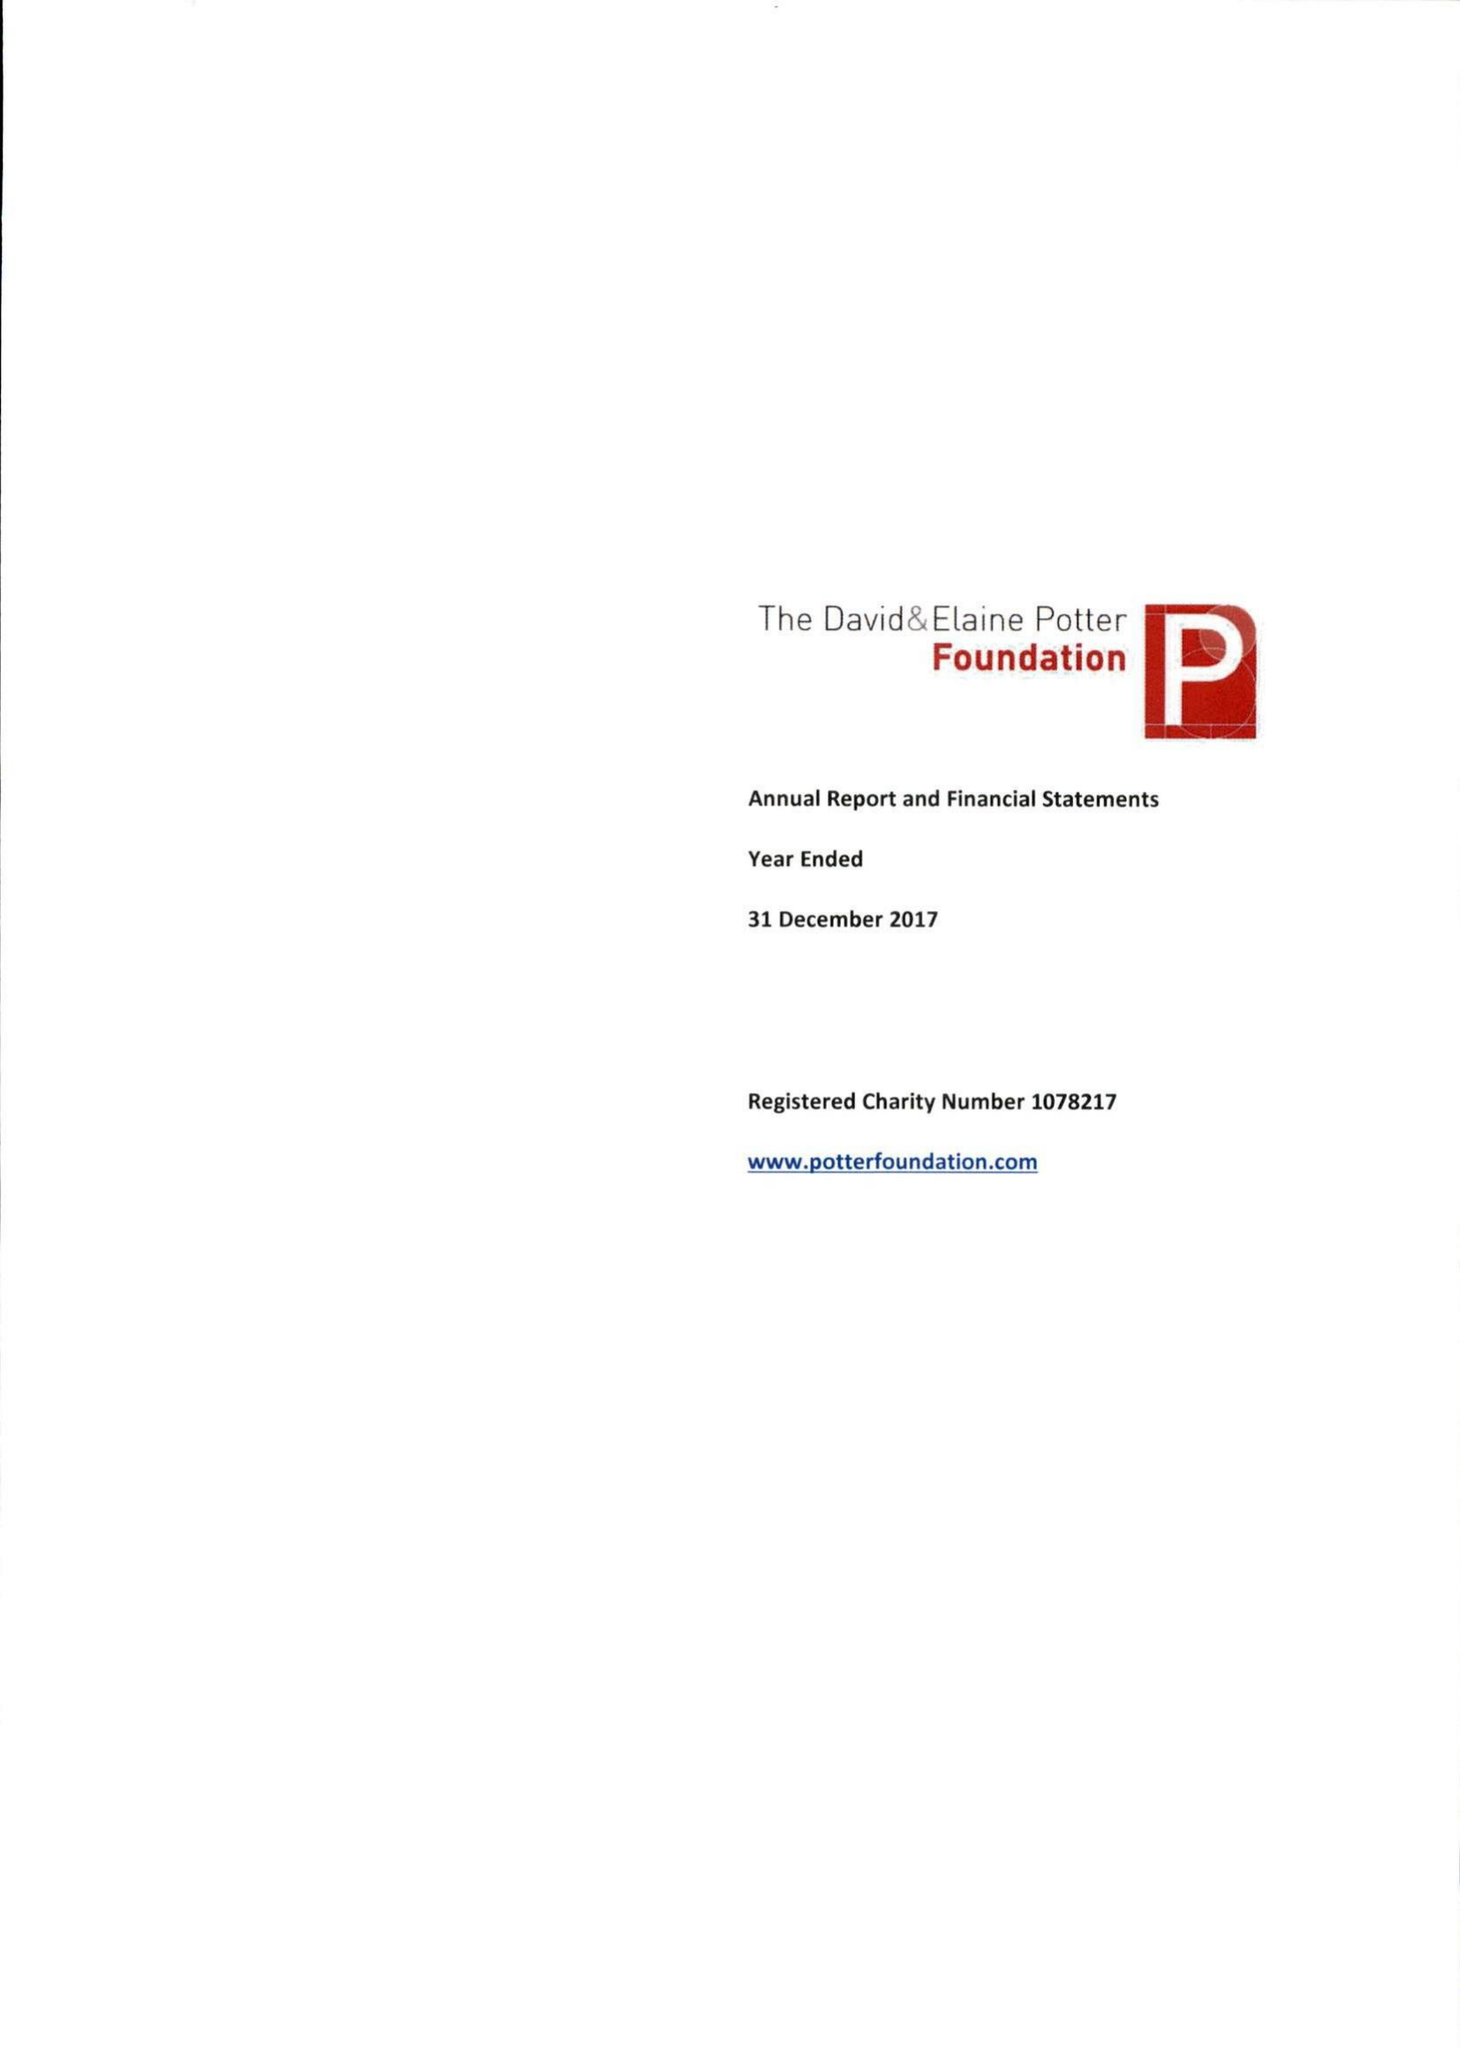What is the value for the address__street_line?
Answer the question using a single word or phrase. 5 WELBECK STREET 